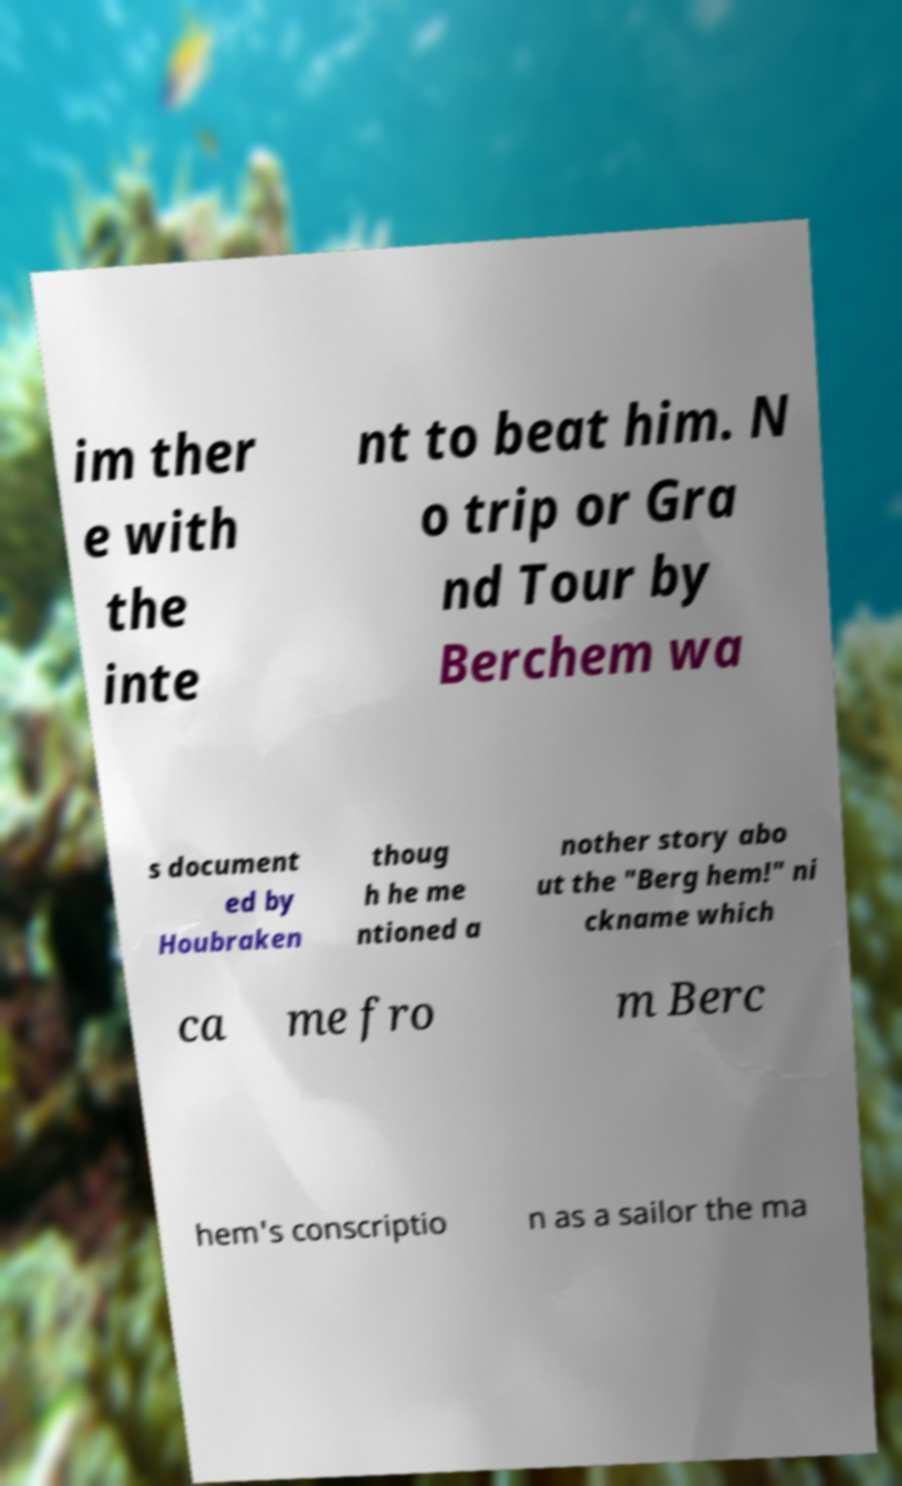There's text embedded in this image that I need extracted. Can you transcribe it verbatim? im ther e with the inte nt to beat him. N o trip or Gra nd Tour by Berchem wa s document ed by Houbraken thoug h he me ntioned a nother story abo ut the "Berg hem!" ni ckname which ca me fro m Berc hem's conscriptio n as a sailor the ma 